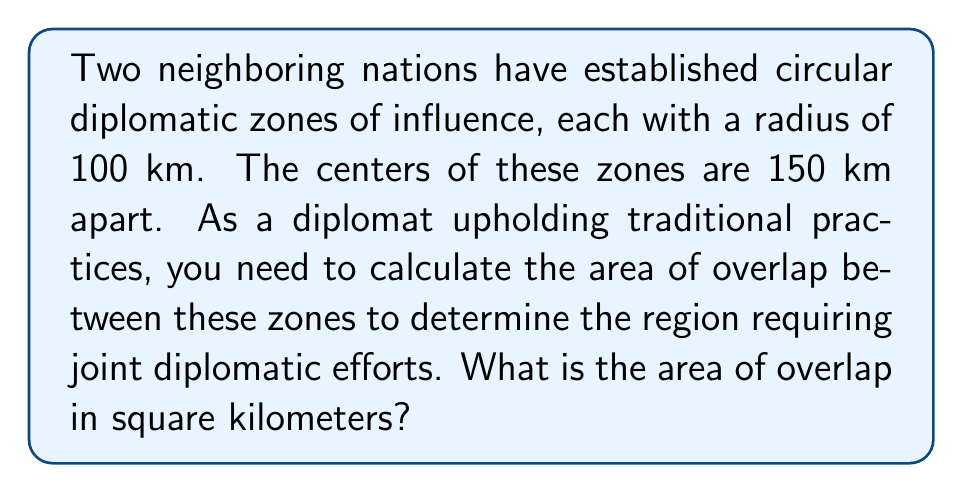Solve this math problem. Let's approach this step-by-step:

1) We have two circles with equal radii $r = 100$ km, and their centers are $d = 150$ km apart.

2) The area of overlap of two circles is given by the formula:

   $$A = 2r^2 \arccos(\frac{d}{2r}) - d\sqrt{r^2 - (\frac{d}{2})^2}$$

3) Let's substitute our values:

   $$A = 2(100^2) \arccos(\frac{150}{2(100)}) - 150\sqrt{100^2 - (\frac{150}{2})^2}$$

4) Simplify inside the arccos and under the square root:

   $$A = 20000 \arccos(0.75) - 150\sqrt{10000 - 5625}$$

5) Evaluate:

   $$A = 20000 (0.7227) - 150(75)$$
   
   $$A = 14454 - 11250$$

6) Calculate the final result:

   $$A = 3204$$ km²

[asy]
unitsize(0.02cm);
pair O1 = (0,0), O2 = (150,0);
draw(circle(O1,100));
draw(circle(O2,100));
draw(O1--O2,dashed);
label("100 km", (50,90), N);
label("150 km", (75,-10), S);
[/asy]
Answer: 3204 km² 